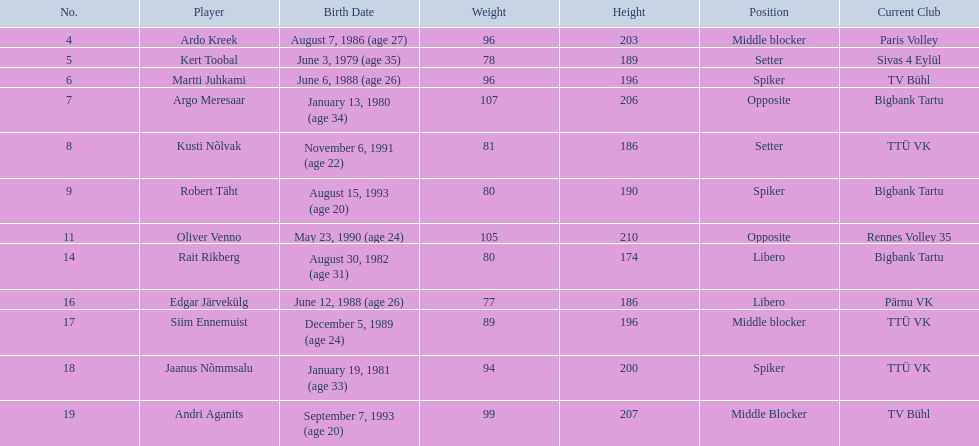What are the altitudes in cm of the men in the squad? 203, 189, 196, 206, 186, 190, 210, 174, 186, 196, 200, 207. What is the loftiest altitude of a squad member? 210. Which sportsman measures 210? Oliver Venno. 